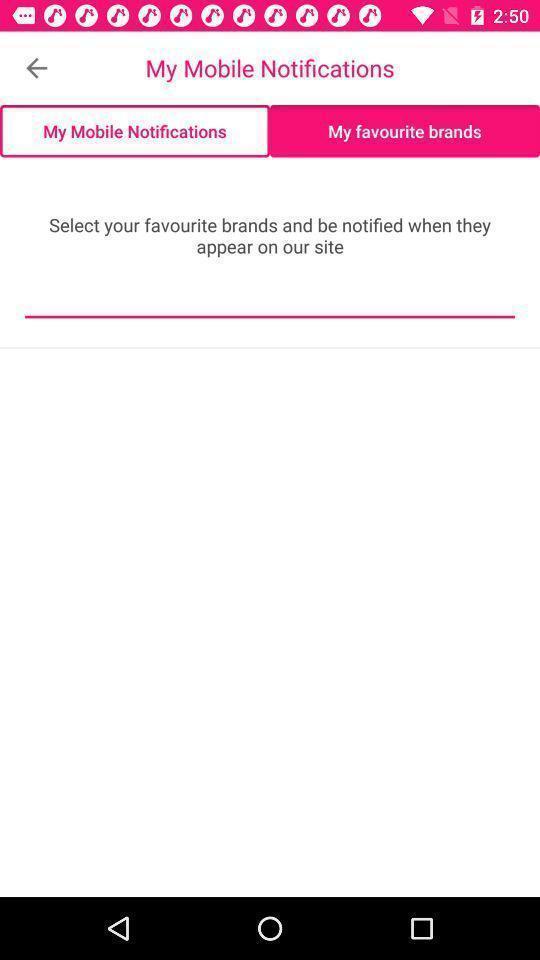Provide a textual representation of this image. Screen displaying multiple options in notifications page. 